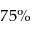Convert formula to latex. <formula><loc_0><loc_0><loc_500><loc_500>7 5 \%</formula> 